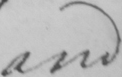What is written in this line of handwriting? and 